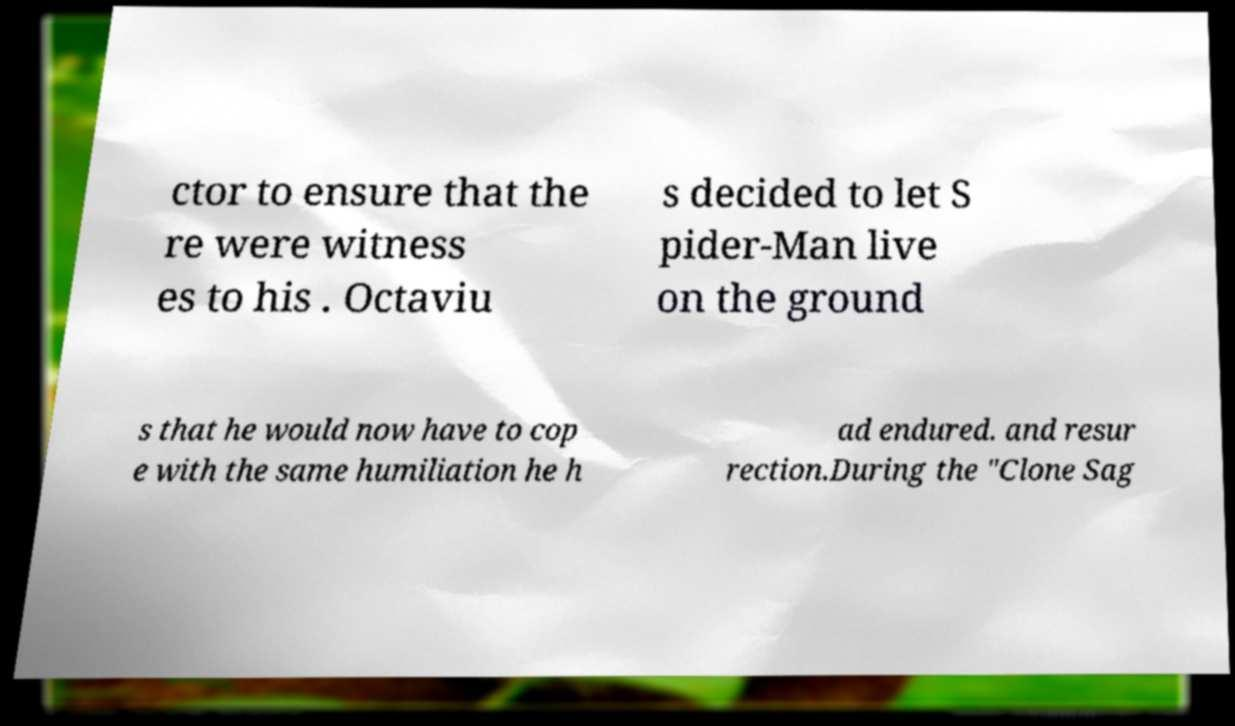Can you accurately transcribe the text from the provided image for me? ctor to ensure that the re were witness es to his . Octaviu s decided to let S pider-Man live on the ground s that he would now have to cop e with the same humiliation he h ad endured. and resur rection.During the "Clone Sag 